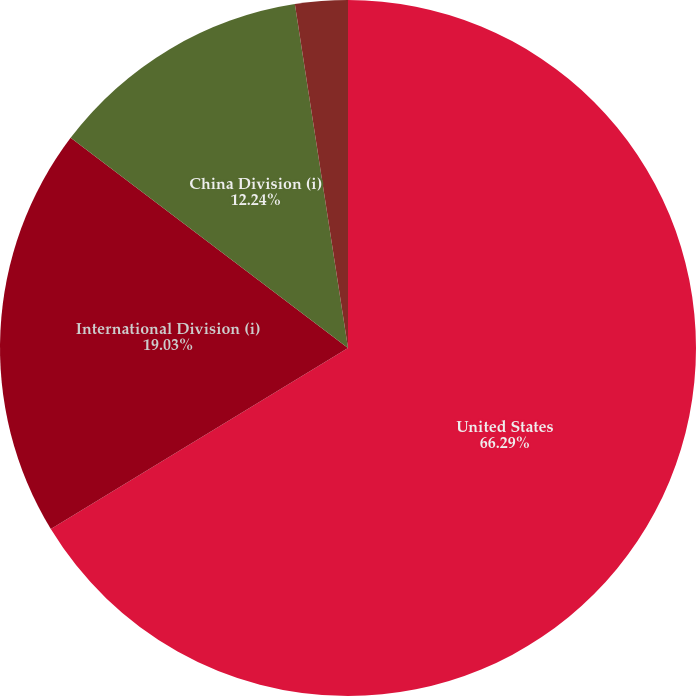Convert chart. <chart><loc_0><loc_0><loc_500><loc_500><pie_chart><fcel>United States<fcel>International Division (i)<fcel>China Division (i)<fcel>Corporate<nl><fcel>66.29%<fcel>19.03%<fcel>12.24%<fcel>2.44%<nl></chart> 